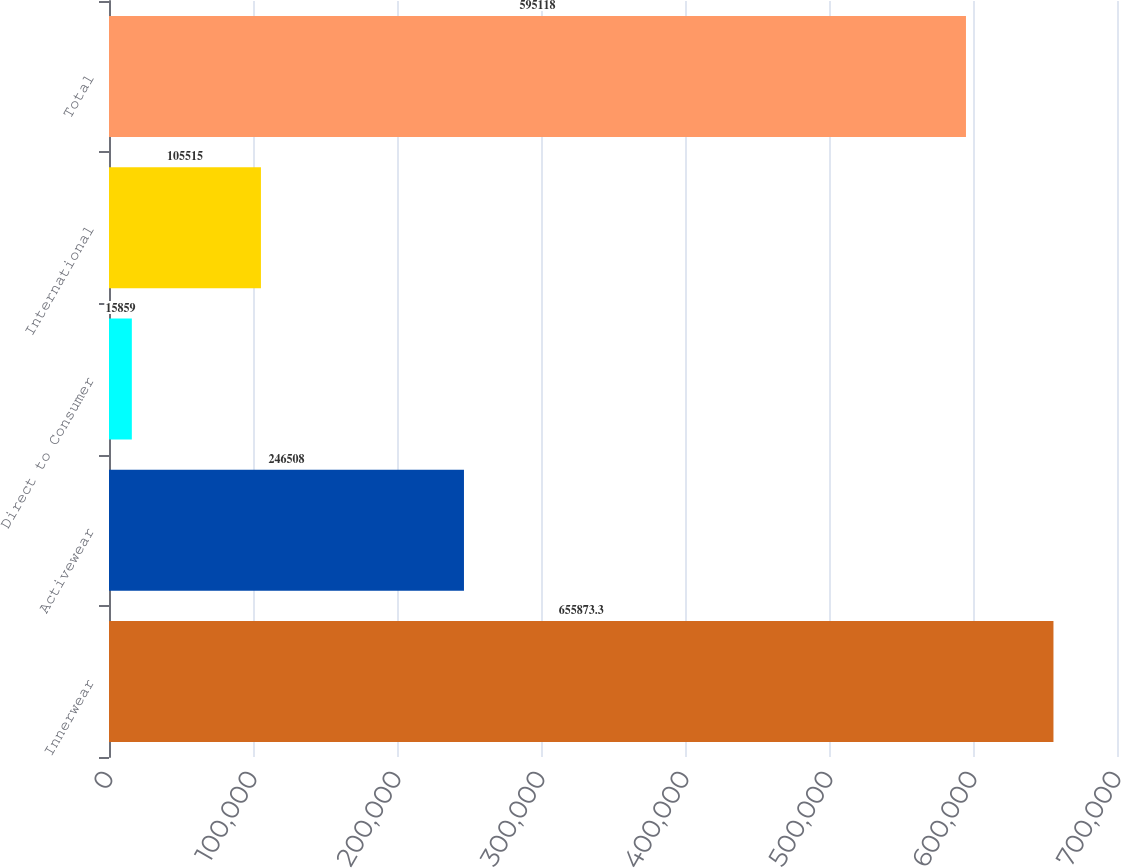Convert chart. <chart><loc_0><loc_0><loc_500><loc_500><bar_chart><fcel>Innerwear<fcel>Activewear<fcel>Direct to Consumer<fcel>International<fcel>Total<nl><fcel>655873<fcel>246508<fcel>15859<fcel>105515<fcel>595118<nl></chart> 